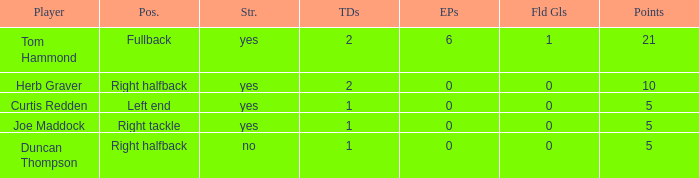Name the fewest touchdowns 1.0. 